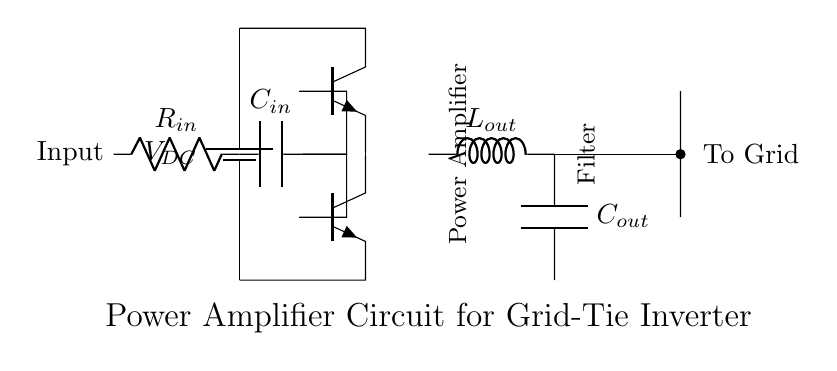What is the type of power source in this circuit? The circuit uses a DC battery as the power source, indicated by the symbol for a battery. This is visually represented at the leftmost part of the diagram.
Answer: DC battery How many transistors are used in this amplifier circuit? There are two transistors shown in the circuit, both labeled as npn transistors. They are positioned vertically along the center of the diagram.
Answer: Two What is the function of the capacitor labeled C out? The capacitor labeled C out serves to filter the output, smoothing the signal before it is sent to the grid. This function is indicated by its position following the inductor in the circuit path.
Answer: Filtering Which components are responsible for input to the amplifier? The input to the amplifier is managed by a resistor and a capacitor, labeled R in and C in respectively. They are shown connected between the input point and the base of the transistors.
Answer: Resistor and capacitor What component directly connects the amplifier output to the grid? The output from the amplifier is directed to the grid via a short connection indicated in the diagram, specifically from the output side of the circuit to a point labeled "To Grid."
Answer: Short connection What type of circuit is represented in this diagram? This circuit represents a power amplifier system as it is designed to increase the output power for grid-tie applications in a wind energy system. The title of the diagram clearly states this.
Answer: Power amplifier 